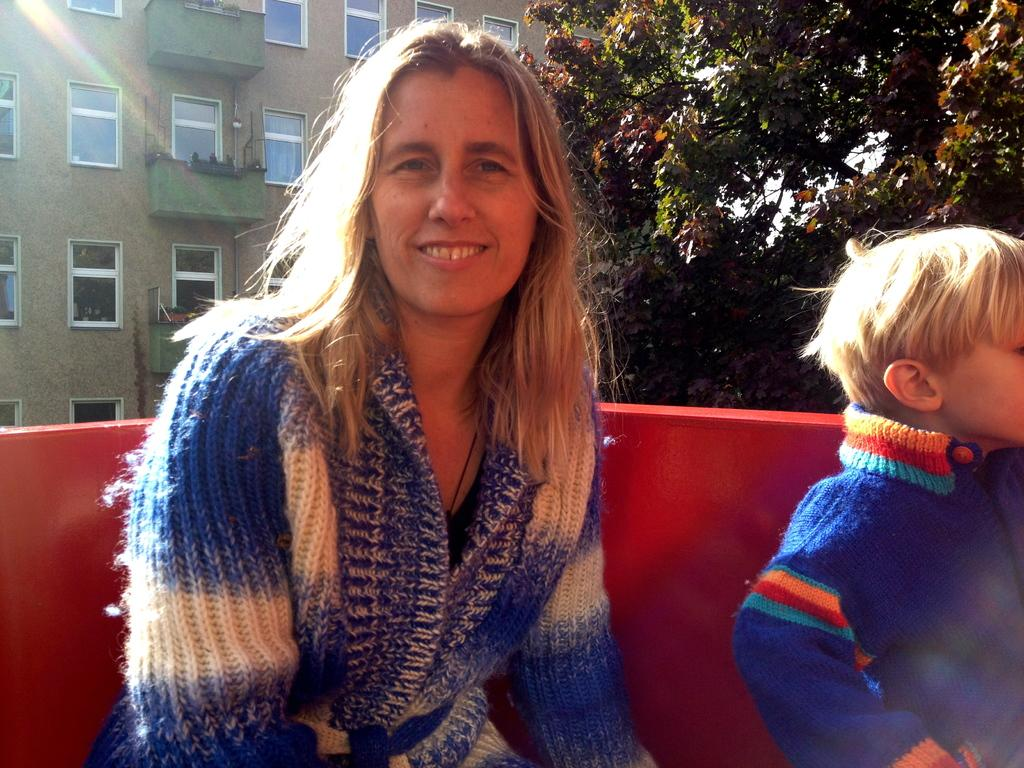Who is present in the image? There is a woman in the image. What is the woman doing in the image? The woman is smiling in the image. Who is with the woman in the image? There is a kid beside the woman in the image. What can be seen in the background of the image? There is a building and trees in the background of the image. What type of grain is being harvested by the woman in the image? There is no grain or harvesting activity present in the image; it features a woman smiling with a kid beside her. What kind of brush is the woman using to paint the trees in the background? There is no brush or painting activity present in the image; it features a woman smiling with a kid beside her and a background with trees and a building. 